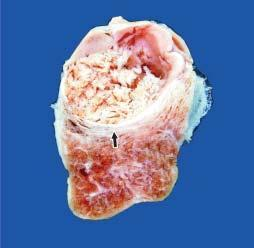s the nodule grey-white soft?
Answer the question using a single word or phrase. Yes 